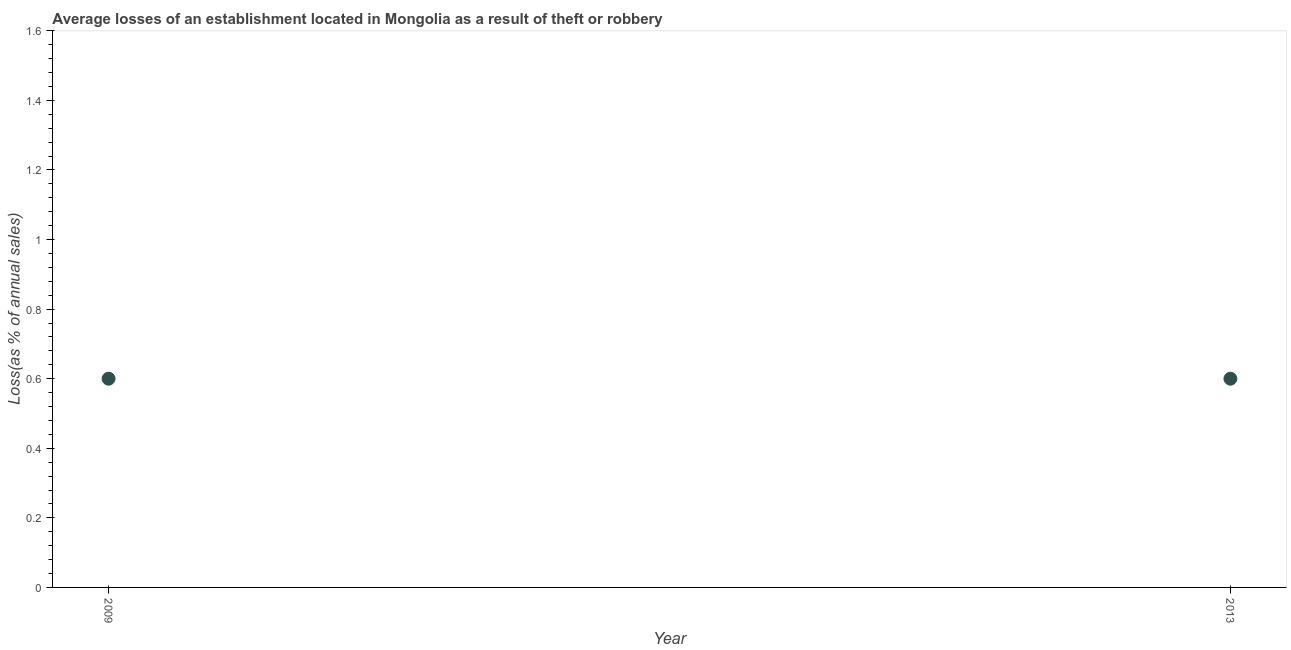In which year was the losses due to theft minimum?
Your answer should be compact. 2009. What is the sum of the losses due to theft?
Offer a very short reply. 1.2. What is the median losses due to theft?
Ensure brevity in your answer.  0.6. In how many years, is the losses due to theft greater than 0.8400000000000001 %?
Your answer should be compact. 0. What is the ratio of the losses due to theft in 2009 to that in 2013?
Offer a very short reply. 1. Does the losses due to theft monotonically increase over the years?
Your answer should be compact. No. Are the values on the major ticks of Y-axis written in scientific E-notation?
Your answer should be very brief. No. Does the graph contain grids?
Your response must be concise. No. What is the title of the graph?
Your response must be concise. Average losses of an establishment located in Mongolia as a result of theft or robbery. What is the label or title of the X-axis?
Your response must be concise. Year. What is the label or title of the Y-axis?
Your answer should be compact. Loss(as % of annual sales). What is the Loss(as % of annual sales) in 2013?
Provide a short and direct response. 0.6. What is the difference between the Loss(as % of annual sales) in 2009 and 2013?
Provide a succinct answer. 0. What is the ratio of the Loss(as % of annual sales) in 2009 to that in 2013?
Your answer should be compact. 1. 